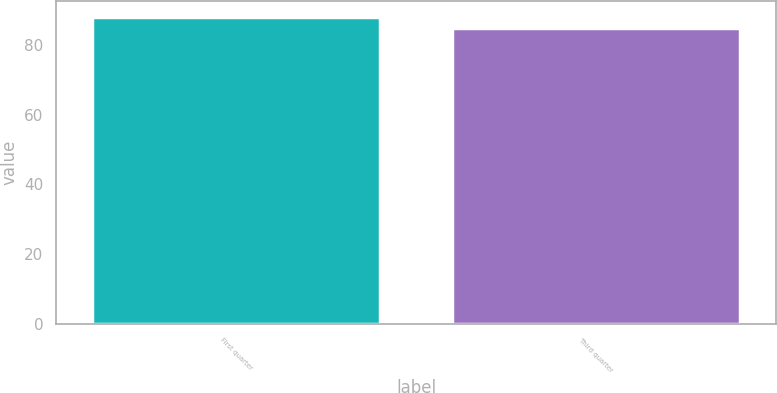Convert chart. <chart><loc_0><loc_0><loc_500><loc_500><bar_chart><fcel>First quarter<fcel>Third quarter<nl><fcel>88.2<fcel>85<nl></chart> 